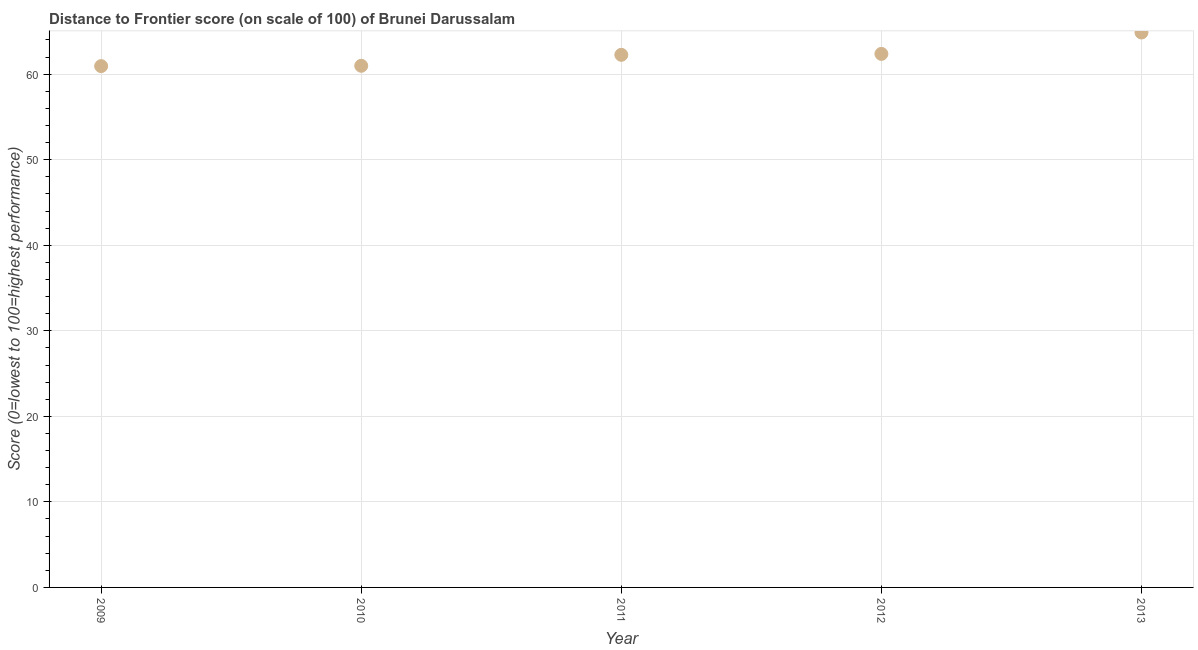What is the distance to frontier score in 2010?
Your answer should be compact. 60.98. Across all years, what is the maximum distance to frontier score?
Keep it short and to the point. 64.87. Across all years, what is the minimum distance to frontier score?
Give a very brief answer. 60.94. In which year was the distance to frontier score minimum?
Offer a very short reply. 2009. What is the sum of the distance to frontier score?
Ensure brevity in your answer.  311.42. What is the difference between the distance to frontier score in 2009 and 2012?
Keep it short and to the point. -1.43. What is the average distance to frontier score per year?
Provide a succinct answer. 62.28. What is the median distance to frontier score?
Your answer should be very brief. 62.26. In how many years, is the distance to frontier score greater than 44 ?
Give a very brief answer. 5. Do a majority of the years between 2012 and 2009 (inclusive) have distance to frontier score greater than 18 ?
Give a very brief answer. Yes. What is the ratio of the distance to frontier score in 2009 to that in 2012?
Your answer should be compact. 0.98. Is the difference between the distance to frontier score in 2009 and 2011 greater than the difference between any two years?
Provide a succinct answer. No. What is the difference between the highest and the second highest distance to frontier score?
Provide a short and direct response. 2.5. What is the difference between the highest and the lowest distance to frontier score?
Provide a short and direct response. 3.93. Does the distance to frontier score monotonically increase over the years?
Your answer should be compact. Yes. How many dotlines are there?
Give a very brief answer. 1. How many years are there in the graph?
Your answer should be very brief. 5. What is the difference between two consecutive major ticks on the Y-axis?
Give a very brief answer. 10. Are the values on the major ticks of Y-axis written in scientific E-notation?
Give a very brief answer. No. Does the graph contain grids?
Make the answer very short. Yes. What is the title of the graph?
Give a very brief answer. Distance to Frontier score (on scale of 100) of Brunei Darussalam. What is the label or title of the Y-axis?
Your response must be concise. Score (0=lowest to 100=highest performance). What is the Score (0=lowest to 100=highest performance) in 2009?
Your answer should be very brief. 60.94. What is the Score (0=lowest to 100=highest performance) in 2010?
Offer a terse response. 60.98. What is the Score (0=lowest to 100=highest performance) in 2011?
Ensure brevity in your answer.  62.26. What is the Score (0=lowest to 100=highest performance) in 2012?
Your answer should be very brief. 62.37. What is the Score (0=lowest to 100=highest performance) in 2013?
Your answer should be compact. 64.87. What is the difference between the Score (0=lowest to 100=highest performance) in 2009 and 2010?
Offer a terse response. -0.04. What is the difference between the Score (0=lowest to 100=highest performance) in 2009 and 2011?
Keep it short and to the point. -1.32. What is the difference between the Score (0=lowest to 100=highest performance) in 2009 and 2012?
Make the answer very short. -1.43. What is the difference between the Score (0=lowest to 100=highest performance) in 2009 and 2013?
Ensure brevity in your answer.  -3.93. What is the difference between the Score (0=lowest to 100=highest performance) in 2010 and 2011?
Your response must be concise. -1.28. What is the difference between the Score (0=lowest to 100=highest performance) in 2010 and 2012?
Your answer should be very brief. -1.39. What is the difference between the Score (0=lowest to 100=highest performance) in 2010 and 2013?
Your response must be concise. -3.89. What is the difference between the Score (0=lowest to 100=highest performance) in 2011 and 2012?
Your response must be concise. -0.11. What is the difference between the Score (0=lowest to 100=highest performance) in 2011 and 2013?
Ensure brevity in your answer.  -2.61. What is the difference between the Score (0=lowest to 100=highest performance) in 2012 and 2013?
Your response must be concise. -2.5. What is the ratio of the Score (0=lowest to 100=highest performance) in 2009 to that in 2012?
Make the answer very short. 0.98. What is the ratio of the Score (0=lowest to 100=highest performance) in 2009 to that in 2013?
Ensure brevity in your answer.  0.94. What is the ratio of the Score (0=lowest to 100=highest performance) in 2010 to that in 2011?
Your answer should be compact. 0.98. What is the ratio of the Score (0=lowest to 100=highest performance) in 2010 to that in 2012?
Offer a very short reply. 0.98. What is the ratio of the Score (0=lowest to 100=highest performance) in 2012 to that in 2013?
Provide a succinct answer. 0.96. 